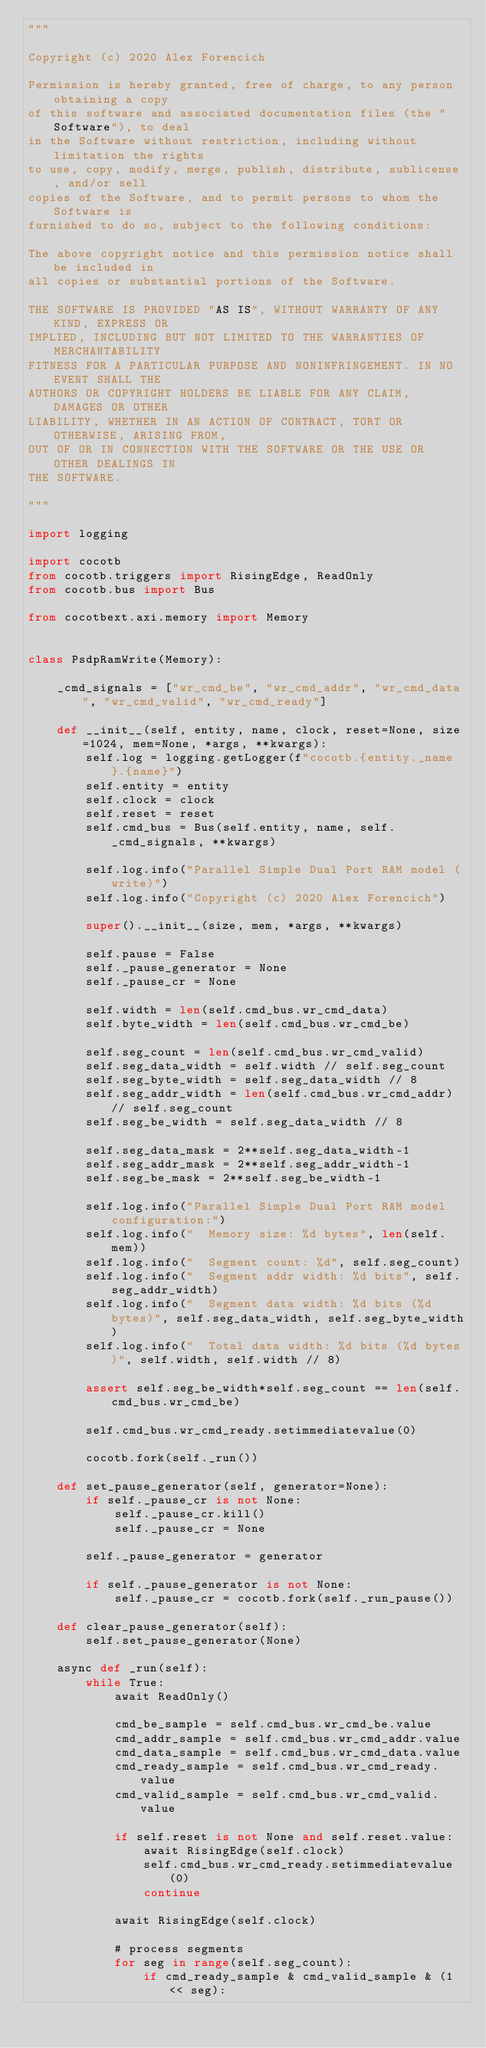<code> <loc_0><loc_0><loc_500><loc_500><_Python_>"""

Copyright (c) 2020 Alex Forencich

Permission is hereby granted, free of charge, to any person obtaining a copy
of this software and associated documentation files (the "Software"), to deal
in the Software without restriction, including without limitation the rights
to use, copy, modify, merge, publish, distribute, sublicense, and/or sell
copies of the Software, and to permit persons to whom the Software is
furnished to do so, subject to the following conditions:

The above copyright notice and this permission notice shall be included in
all copies or substantial portions of the Software.

THE SOFTWARE IS PROVIDED "AS IS", WITHOUT WARRANTY OF ANY KIND, EXPRESS OR
IMPLIED, INCLUDING BUT NOT LIMITED TO THE WARRANTIES OF MERCHANTABILITY
FITNESS FOR A PARTICULAR PURPOSE AND NONINFRINGEMENT. IN NO EVENT SHALL THE
AUTHORS OR COPYRIGHT HOLDERS BE LIABLE FOR ANY CLAIM, DAMAGES OR OTHER
LIABILITY, WHETHER IN AN ACTION OF CONTRACT, TORT OR OTHERWISE, ARISING FROM,
OUT OF OR IN CONNECTION WITH THE SOFTWARE OR THE USE OR OTHER DEALINGS IN
THE SOFTWARE.

"""

import logging

import cocotb
from cocotb.triggers import RisingEdge, ReadOnly
from cocotb.bus import Bus

from cocotbext.axi.memory import Memory


class PsdpRamWrite(Memory):

    _cmd_signals = ["wr_cmd_be", "wr_cmd_addr", "wr_cmd_data", "wr_cmd_valid", "wr_cmd_ready"]

    def __init__(self, entity, name, clock, reset=None, size=1024, mem=None, *args, **kwargs):
        self.log = logging.getLogger(f"cocotb.{entity._name}.{name}")
        self.entity = entity
        self.clock = clock
        self.reset = reset
        self.cmd_bus = Bus(self.entity, name, self._cmd_signals, **kwargs)

        self.log.info("Parallel Simple Dual Port RAM model (write)")
        self.log.info("Copyright (c) 2020 Alex Forencich")

        super().__init__(size, mem, *args, **kwargs)

        self.pause = False
        self._pause_generator = None
        self._pause_cr = None

        self.width = len(self.cmd_bus.wr_cmd_data)
        self.byte_width = len(self.cmd_bus.wr_cmd_be)

        self.seg_count = len(self.cmd_bus.wr_cmd_valid)
        self.seg_data_width = self.width // self.seg_count
        self.seg_byte_width = self.seg_data_width // 8
        self.seg_addr_width = len(self.cmd_bus.wr_cmd_addr) // self.seg_count
        self.seg_be_width = self.seg_data_width // 8

        self.seg_data_mask = 2**self.seg_data_width-1
        self.seg_addr_mask = 2**self.seg_addr_width-1
        self.seg_be_mask = 2**self.seg_be_width-1

        self.log.info("Parallel Simple Dual Port RAM model configuration:")
        self.log.info("  Memory size: %d bytes", len(self.mem))
        self.log.info("  Segment count: %d", self.seg_count)
        self.log.info("  Segment addr width: %d bits", self.seg_addr_width)
        self.log.info("  Segment data width: %d bits (%d bytes)", self.seg_data_width, self.seg_byte_width)
        self.log.info("  Total data width: %d bits (%d bytes)", self.width, self.width // 8)

        assert self.seg_be_width*self.seg_count == len(self.cmd_bus.wr_cmd_be)

        self.cmd_bus.wr_cmd_ready.setimmediatevalue(0)

        cocotb.fork(self._run())

    def set_pause_generator(self, generator=None):
        if self._pause_cr is not None:
            self._pause_cr.kill()
            self._pause_cr = None

        self._pause_generator = generator

        if self._pause_generator is not None:
            self._pause_cr = cocotb.fork(self._run_pause())

    def clear_pause_generator(self):
        self.set_pause_generator(None)

    async def _run(self):
        while True:
            await ReadOnly()

            cmd_be_sample = self.cmd_bus.wr_cmd_be.value
            cmd_addr_sample = self.cmd_bus.wr_cmd_addr.value
            cmd_data_sample = self.cmd_bus.wr_cmd_data.value
            cmd_ready_sample = self.cmd_bus.wr_cmd_ready.value
            cmd_valid_sample = self.cmd_bus.wr_cmd_valid.value

            if self.reset is not None and self.reset.value:
                await RisingEdge(self.clock)
                self.cmd_bus.wr_cmd_ready.setimmediatevalue(0)
                continue

            await RisingEdge(self.clock)

            # process segments
            for seg in range(self.seg_count):
                if cmd_ready_sample & cmd_valid_sample & (1 << seg):</code> 